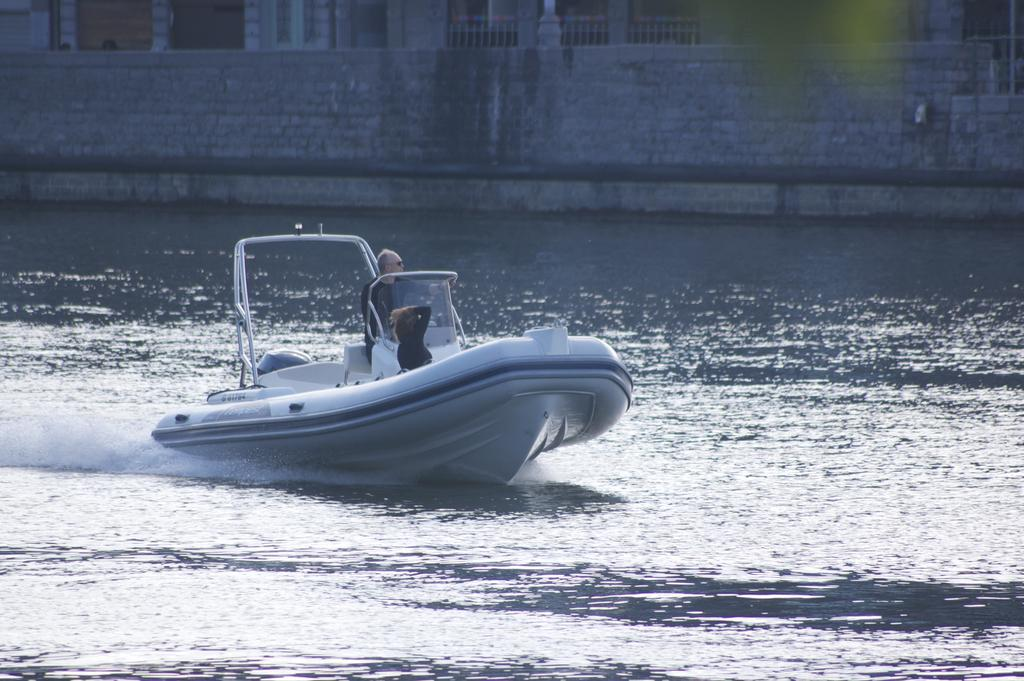Who is in the boat in the image? There is a man and a woman in a boat in the image. Where is the boat located? The boat is placed in the water. What can be seen in the background of the image? There is a building with windows in the image. What architectural features are present on the building? The building has pillars and a railing in the image. What example of an uncle can be seen in the image? There is no uncle present in the image. What day is it in the image? The image does not provide any information about the day. 